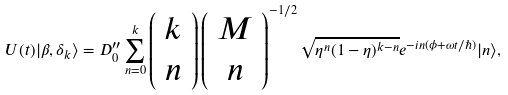<formula> <loc_0><loc_0><loc_500><loc_500>U ( t ) | \beta , \delta _ { k } \rangle = D _ { 0 } ^ { \prime \prime } \sum _ { n = 0 } ^ { k } \left ( \begin{array} { c } k \\ n \end{array} \right ) \left ( \begin{array} { c } M \\ n \end{array} \right ) ^ { - 1 / 2 } \sqrt { \eta ^ { n } ( 1 - \eta ) ^ { k - n } } e ^ { - i n ( \phi + \omega t / \hbar { ) } } | n \rangle ,</formula> 